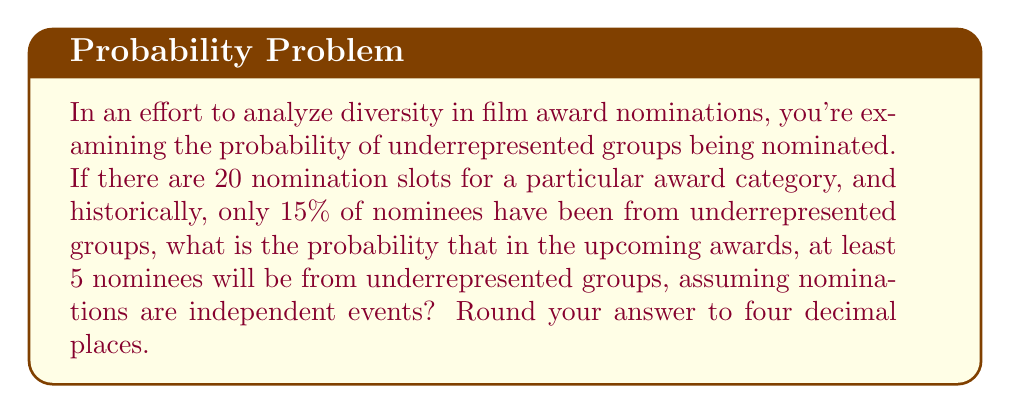Could you help me with this problem? To solve this problem, we'll use the binomial probability distribution.

Step 1: Identify the parameters
- $n = 20$ (number of nomination slots)
- $p = 0.15$ (probability of a nominee being from an underrepresented group)
- We want $P(X \geq 5)$, where $X$ is the number of nominees from underrepresented groups

Step 2: Calculate $P(X \geq 5)$ using the complement rule
$P(X \geq 5) = 1 - P(X < 5) = 1 - P(X \leq 4)$

Step 3: Use the cumulative binomial probability function
$$P(X \leq 4) = \sum_{k=0}^{4} \binom{20}{k} (0.15)^k (0.85)^{20-k}$$

Step 4: Calculate each term
- $k=0$: $\binom{20}{0} (0.15)^0 (0.85)^{20} = 0.0388$
- $k=1$: $\binom{20}{1} (0.15)^1 (0.85)^{19} = 0.1368$
- $k=2$: $\binom{20}{2} (0.15)^2 (0.85)^{18} = 0.2294$
- $k=3$: $\binom{20}{3} (0.15)^3 (0.85)^{17} = 0.2364$
- $k=4$: $\binom{20}{4} (0.15)^4 (0.85)^{16} = 0.1698$

Step 5: Sum the terms
$P(X \leq 4) = 0.0388 + 0.1368 + 0.2294 + 0.2364 + 0.1698 = 0.8112$

Step 6: Calculate the final probability
$P(X \geq 5) = 1 - P(X \leq 4) = 1 - 0.8112 = 0.1888$

Step 7: Round to four decimal places
$0.1888$ rounded to four decimal places is $0.1888$.
Answer: 0.1888 